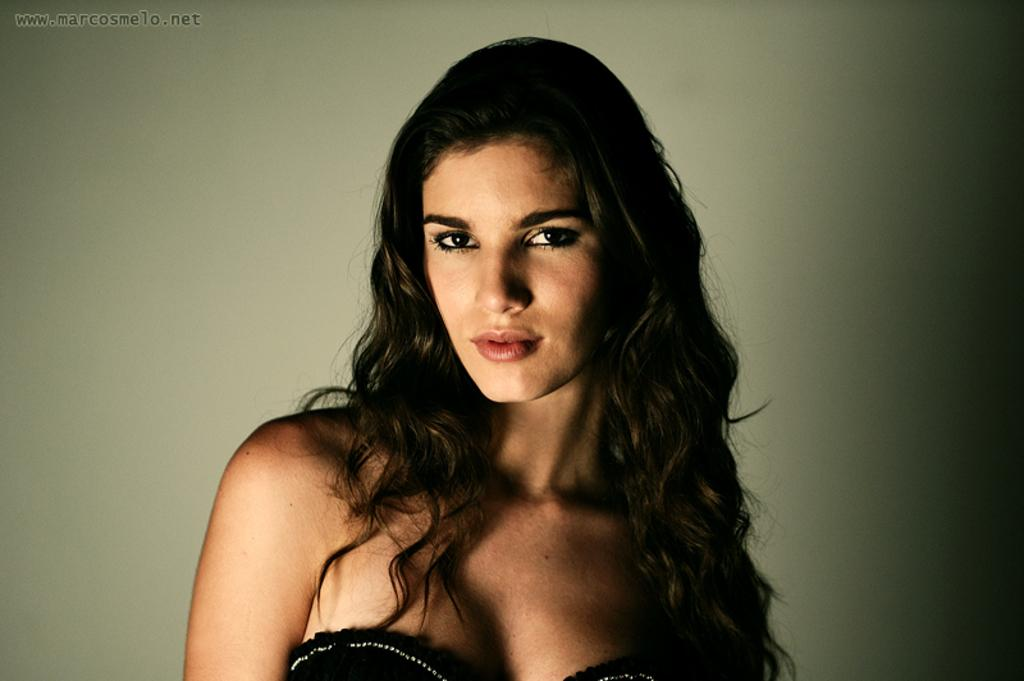Who is the main subject in the image? There is a woman in the image. Where is the woman located in the image? The woman is in the middle of the image. What is the woman wearing in the image? The woman is wearing clothes in the image. Can you describe any additional features of the image? There is a watermark on the top left of the image. What type of voice can be heard coming from the woman in the image? There is no voice present in the image, as it is a still photograph. 